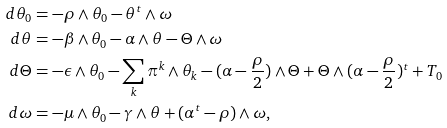Convert formula to latex. <formula><loc_0><loc_0><loc_500><loc_500>d \theta _ { 0 } & = - \rho \wedge \theta _ { 0 } - \theta ^ { t } \wedge \omega \\ d \theta & = - \beta \wedge \theta _ { 0 } - \alpha \wedge \theta - \Theta \wedge \omega \\ d \Theta & = - \epsilon \wedge \theta _ { 0 } - \sum _ { k } \pi ^ { k } \wedge \theta _ { k } - ( \alpha - \frac { \rho } { 2 } ) \wedge \Theta + \Theta \wedge ( \alpha - \frac { \rho } { 2 } ) ^ { t } + T _ { 0 } \\ d \omega & = - \mu \wedge \theta _ { 0 } - \gamma \wedge \theta + ( \alpha ^ { t } - \rho ) \wedge \omega ,</formula> 